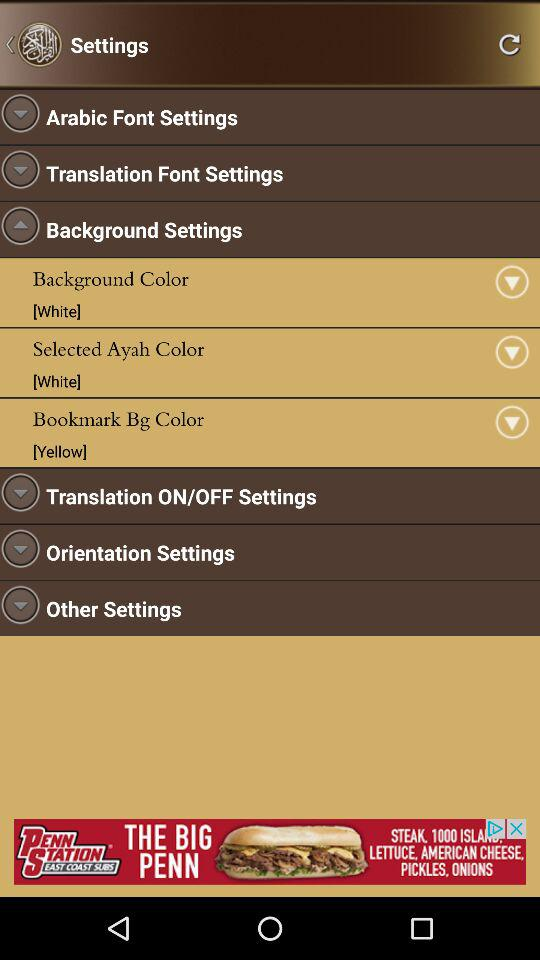What is the selected Ayah color? The selected Ayah color is white. 